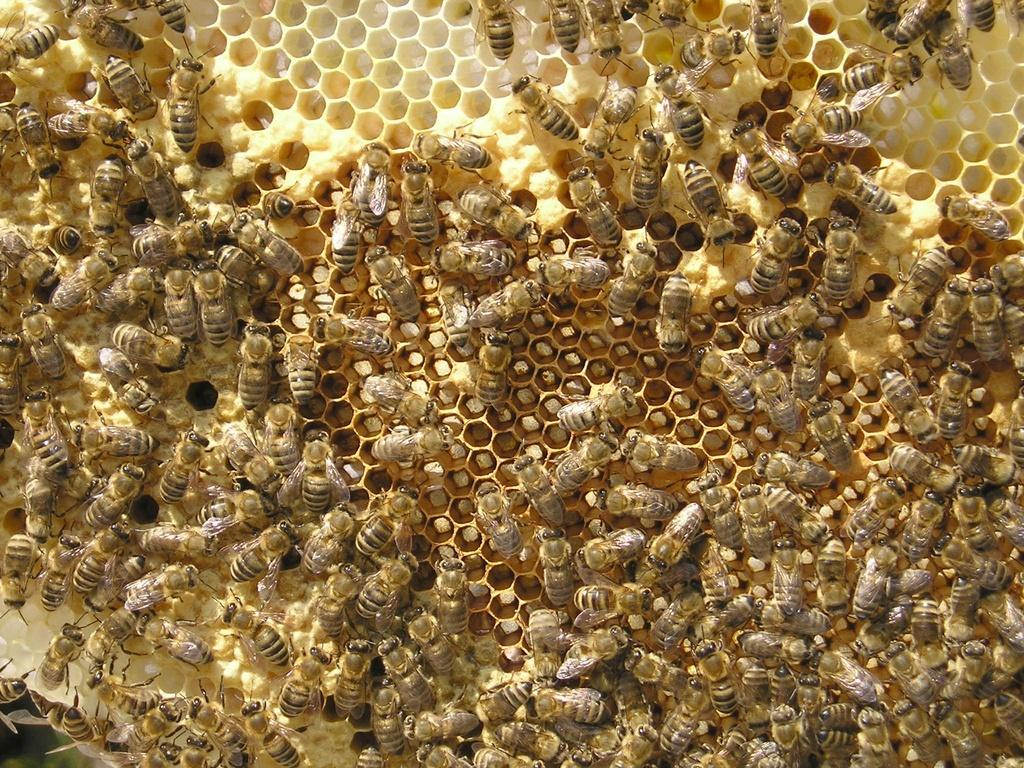What type of insects are present in the image? There is a group of honey bees in the image. Can you describe the behavior of the honey bees in the image? The provided facts do not mention the behavior of the honey bees, so we cannot describe it. What type of mark can be seen on the dog's fur in the image? There is no dog present in the image; it only features a group of honey bees. 